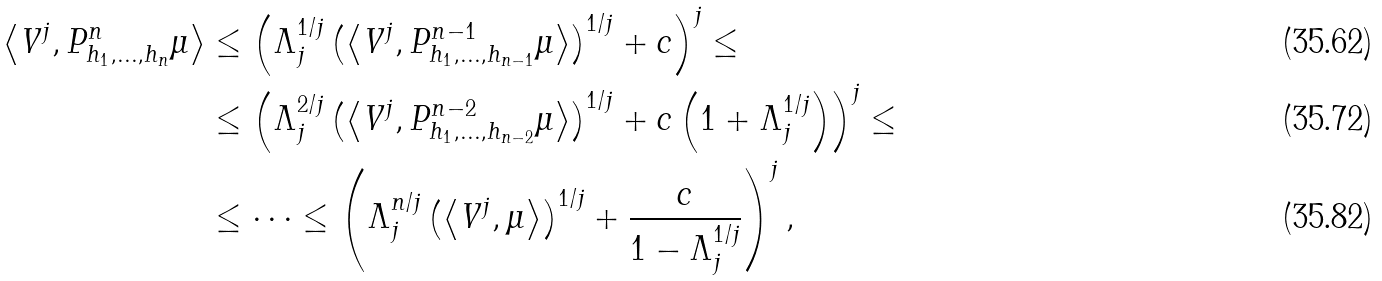Convert formula to latex. <formula><loc_0><loc_0><loc_500><loc_500>\left \langle V ^ { j } , P ^ { n } _ { h _ { 1 } , \dots , h _ { n } } \mu \right \rangle & \leq \left ( \Lambda ^ { 1 / j } _ { j } \left ( \left \langle V ^ { j } , P ^ { n - 1 } _ { h _ { 1 } , \dots , h _ { n - 1 } } \mu \right \rangle \right ) ^ { 1 / j } + c \right ) ^ { j } \leq \\ & \leq \left ( \Lambda ^ { 2 / j } _ { j } \left ( \left \langle V ^ { j } , P ^ { n - 2 } _ { h _ { 1 } , \dots , h _ { n - 2 } } \mu \right \rangle \right ) ^ { 1 / j } + c \left ( 1 + \Lambda _ { j } ^ { 1 / j } \right ) \right ) ^ { j } \leq \\ & \leq \dots \leq \left ( \Lambda _ { j } ^ { n / j } \left ( \left \langle V ^ { j } , \mu \right \rangle \right ) ^ { 1 / j } + \frac { c } { 1 - \Lambda _ { j } ^ { 1 / j } } \right ) ^ { j } ,</formula> 